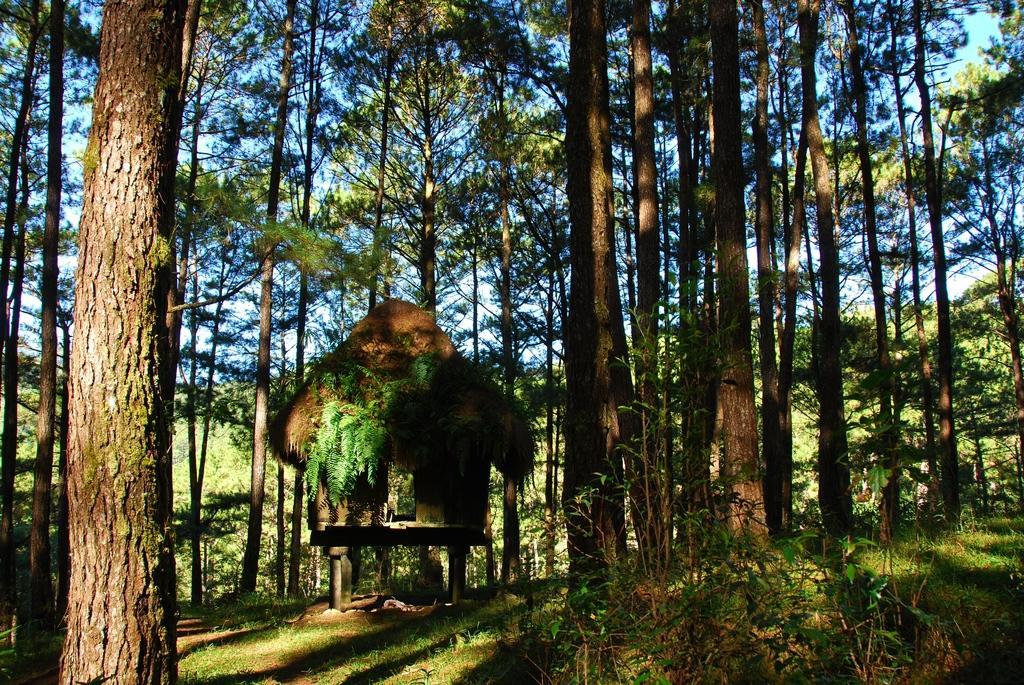Please provide a concise description of this image. In this image I can see few green trees and a hut. The sky is in blue and white color. 